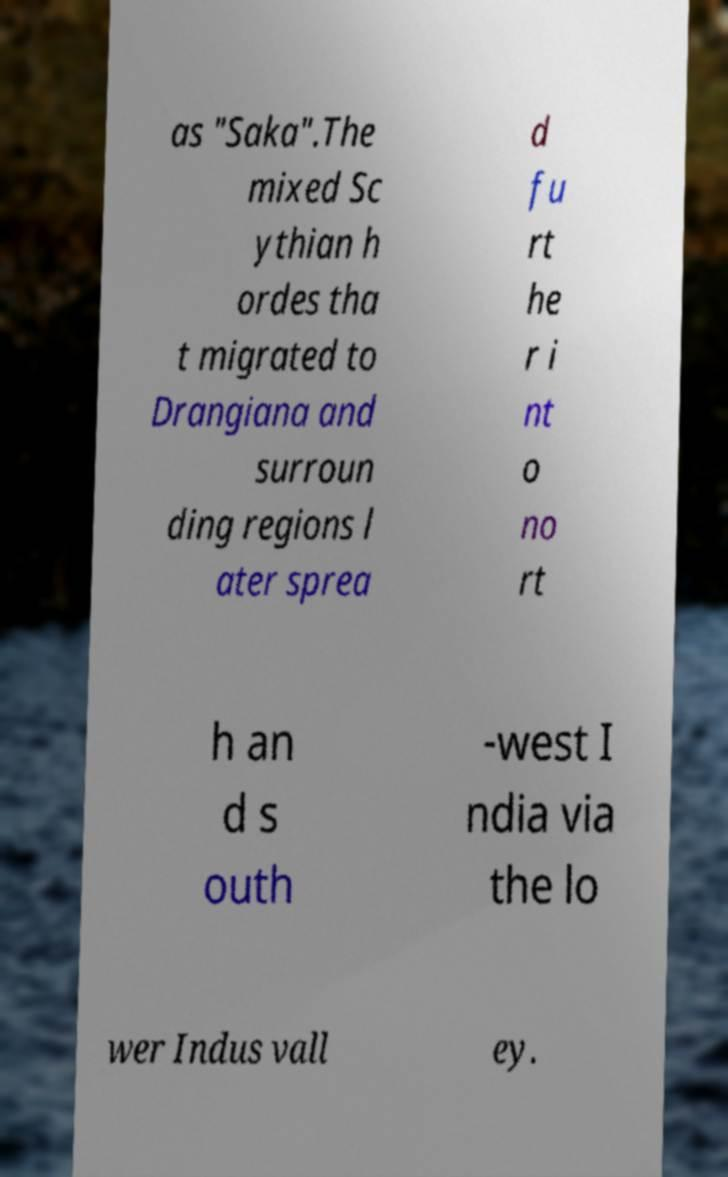For documentation purposes, I need the text within this image transcribed. Could you provide that? as "Saka".The mixed Sc ythian h ordes tha t migrated to Drangiana and surroun ding regions l ater sprea d fu rt he r i nt o no rt h an d s outh -west I ndia via the lo wer Indus vall ey. 